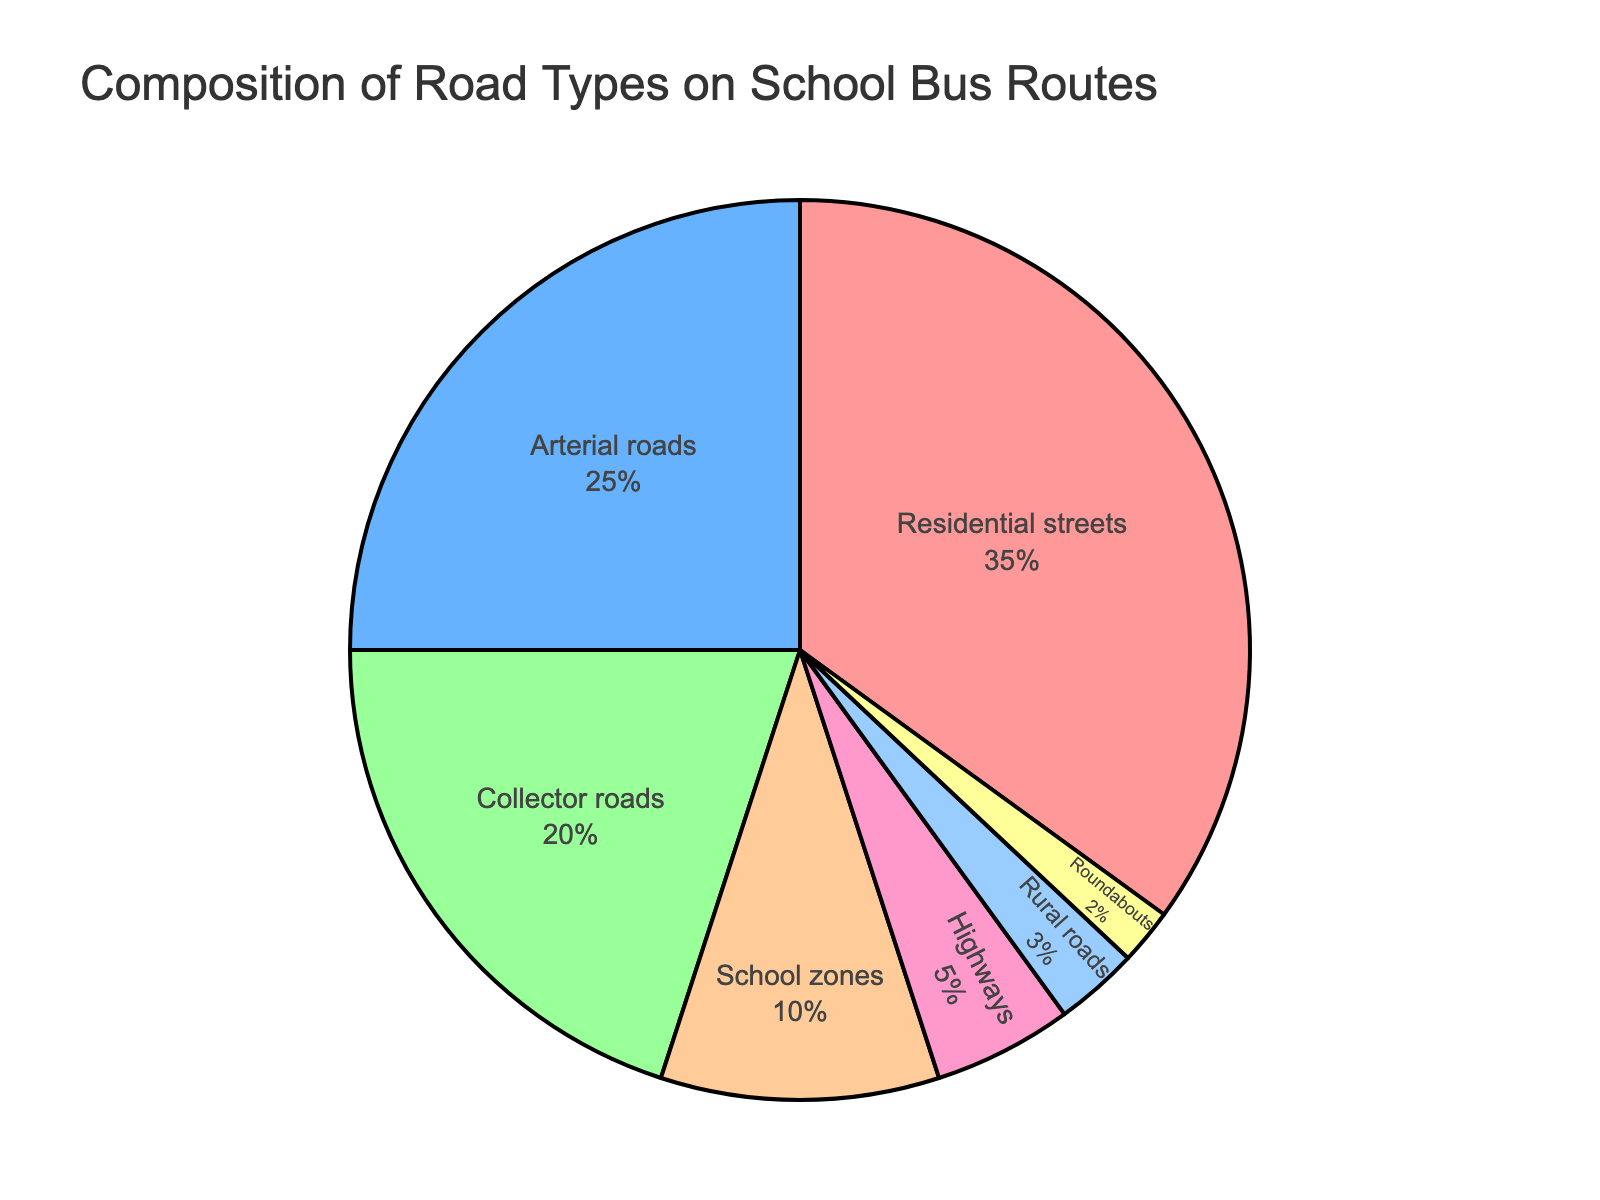Which road type occupies the largest percentage in the figure? The figure shows that the largest slice of the pie chart is labeled "Residential streets" with 35%.
Answer: Residential streets What is the combined percentage of arterial roads and collector roads? From the figure, arterial roads are 25% and collector roads are 20%. Adding them together, 25% + 20% = 45%.
Answer: 45% Is the percentage of rural roads greater than that of roundabouts? The figure shows rural roads at 3% and roundabouts at 2%. Since 3% is greater than 2%, rural roads have a higher percentage.
Answer: Yes Which road type has the smallest percentage, and what is it? The figure indicates that the smallest slice is labeled "Roundabouts" at 2%.
Answer: Roundabouts, 2% How much more percentage do residential streets have compared to school zones? Residential streets are 35% and school zones are 10%. Subtracting the two, 35% - 10% = 25%.
Answer: 25% Do highways and rural roads together comprise more than 10% of the total? Highways are 5% and rural roads are 3%. Adding them together, 5% + 3% = 8%, which is less than 10%.
Answer: No What is the relative difference in percentage between collector roads and highways? The figure shows collector roads at 20% and highways at 5%. Subtracting these, 20% - 5% = 15%.
Answer: 15% Is any road type occupying exactly one-third of the total percentage? One-third of 100% is around 33.33%. The closest is residential streets at 35%, but it's not exactly one-third.
Answer: No What percentage of the pie chart is represented by non-urban road types (highways, rural roads, roundabouts)? The figure shows highways (5%), rural roads (3%), and roundabouts (2%). Adding them together, 5% + 3% + 2% = 10%.
Answer: 10% What percentage difference is there between school zones and rural roads? School zones are 10% and rural roads are 3%. Subtracting these, 10% - 3% = 7%.
Answer: 7% 